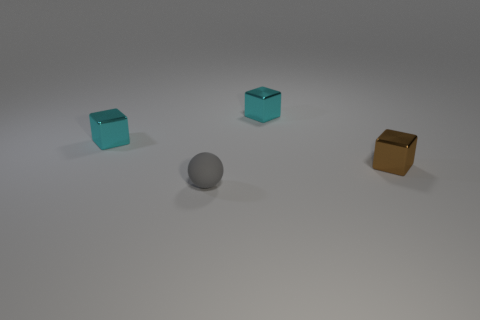Subtract all small cyan blocks. How many blocks are left? 1 Subtract all cyan spheres. How many cyan cubes are left? 2 Add 4 gray matte balls. How many objects exist? 8 Subtract all cyan cubes. How many cubes are left? 1 Subtract all balls. How many objects are left? 3 Subtract 1 spheres. How many spheres are left? 0 Subtract all brown balls. Subtract all gray cylinders. How many balls are left? 1 Subtract all tiny cyan objects. Subtract all rubber objects. How many objects are left? 1 Add 1 brown things. How many brown things are left? 2 Add 3 cyan metal objects. How many cyan metal objects exist? 5 